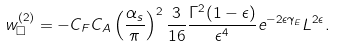Convert formula to latex. <formula><loc_0><loc_0><loc_500><loc_500>w ^ { ( 2 ) } _ { \Box } = - C _ { F } C _ { A } \left ( \frac { \alpha _ { s } } { \pi } \right ) ^ { 2 } \frac { 3 } { 1 6 } \frac { \Gamma ^ { 2 } ( 1 - \epsilon ) } { \epsilon ^ { 4 } } e ^ { - 2 \epsilon \gamma _ { E } } L ^ { 2 \epsilon } .</formula> 